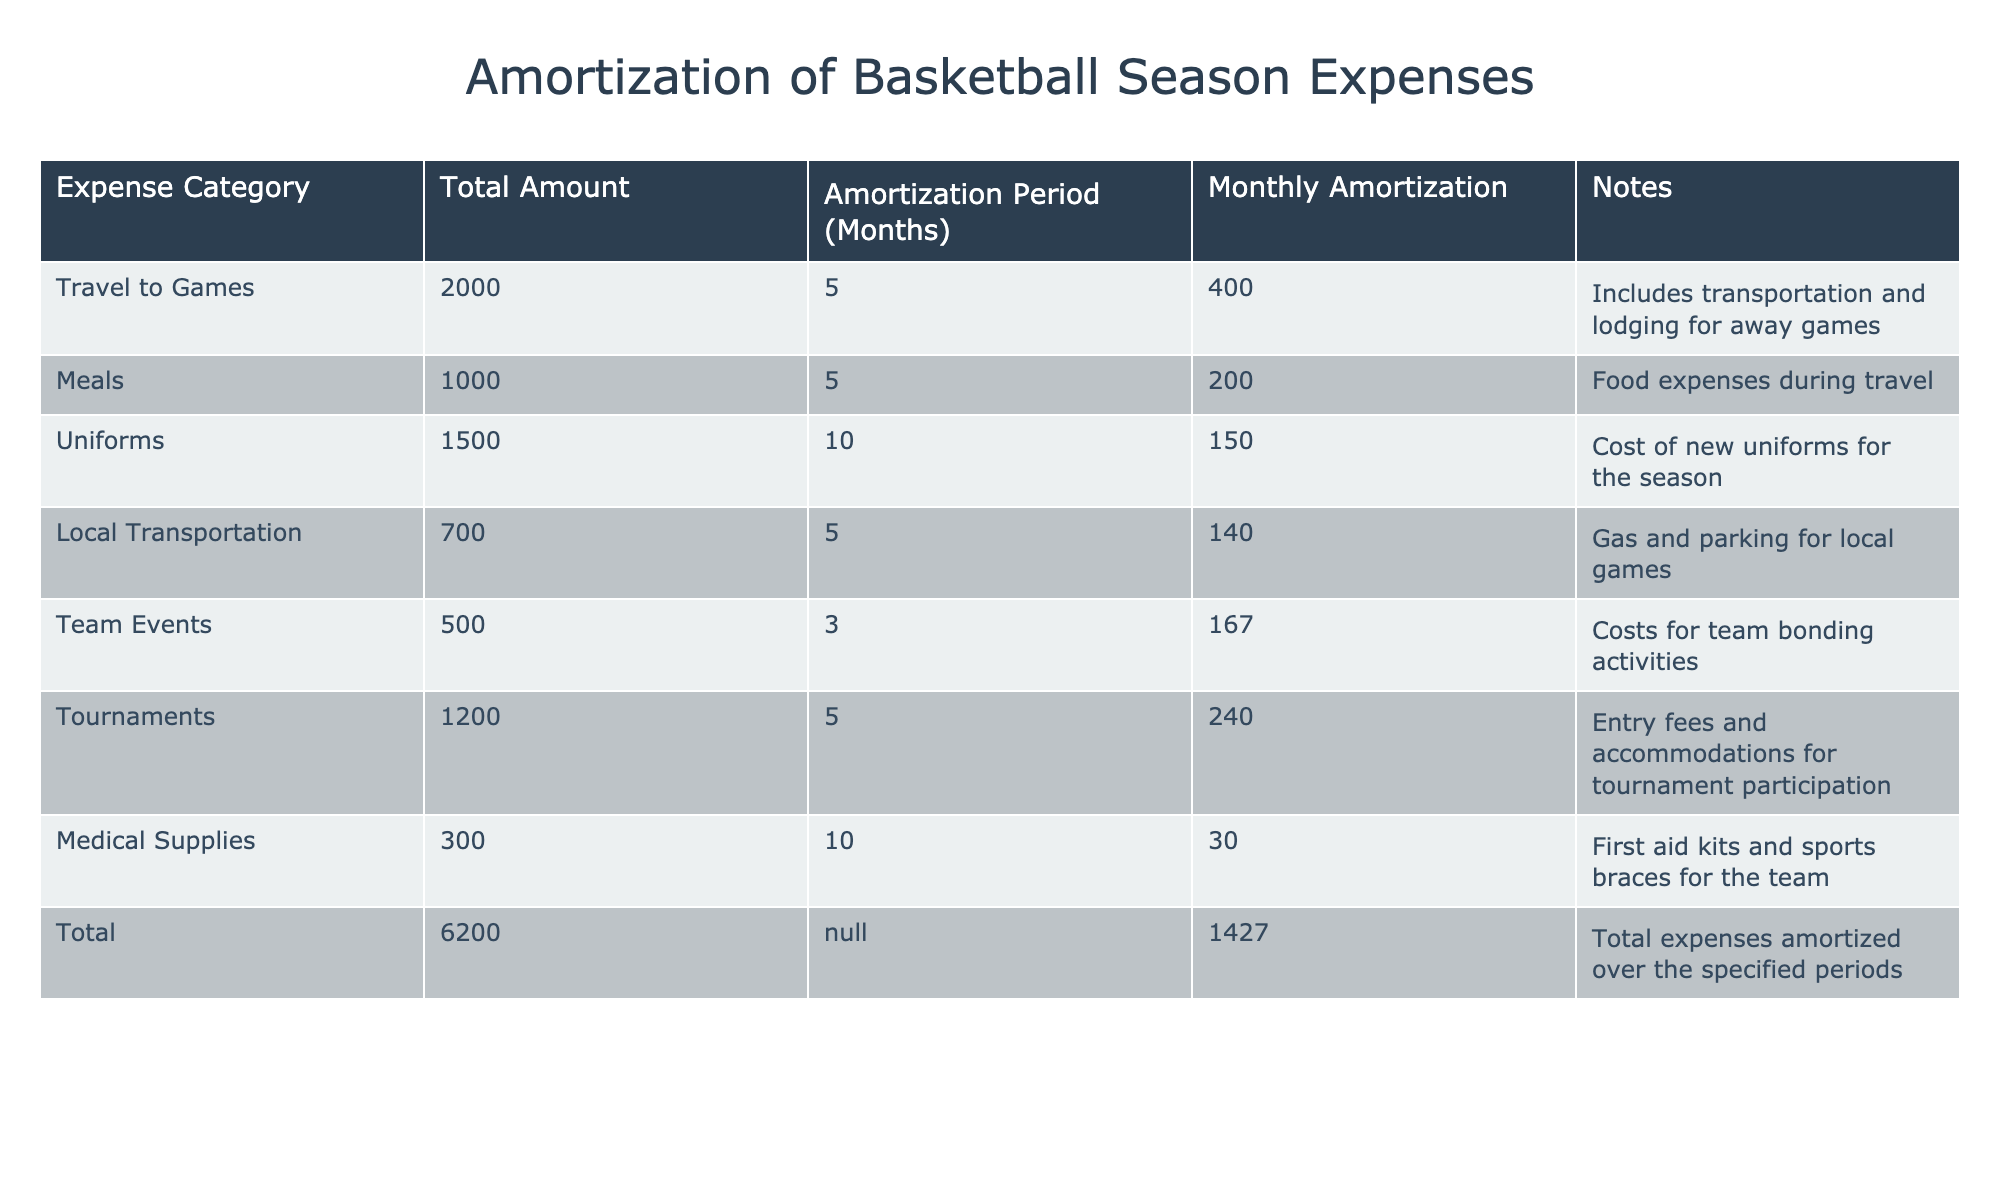What is the total amount allocated for travel to games? The table indicates that the total amount for the "Travel to Games" expense category is 2000.
Answer: 2000 What is the monthly amortization cost of the meal expenses? According to the table, the monthly amortization for meals is listed as 200.
Answer: 200 Which category has the longest amortization period, and what is that period? By reviewing the table, the category with the longest amortization period is "Uniforms" with an amortization period of 10 months.
Answer: Uniforms, 10 months What is the total amount for local transportation and team events combined? To find the combined total, we add the amounts for "Local Transportation" (700) and "Team Events" (500): 700 + 500 = 1200.
Answer: 1200 Is the monthly amortization for the tournament expenses greater than that for meals? The monthly amortization for "Tournaments" is 240, while for "Meals" it is 200. Since 240 is greater than 200, the answer is yes.
Answer: Yes What is the total amortization expense for the basketball season? The table shows the total expense directly listed as 6200. No calculations are needed, as it's provided.
Answer: 6200 What is the average monthly amortization for all categories combined? To calculate the average, we take the total monthly amortization (1427) and divide it by the number of categories (7): 1427 / 7 = approximately 204.
Answer: 204 Which expense category has the lowest total amount allocated? From the table, "Medical Supplies" has the lowest total amount allocated, which is 300.
Answer: Medical Supplies How much will the team spend on uniforms compared to team events? The total amount for "Uniforms" is 1500, while for "Team Events" it is 500. Thus, 1500 is greater than 500, indicating the team spends significantly more on uniforms.
Answer: More on uniforms 